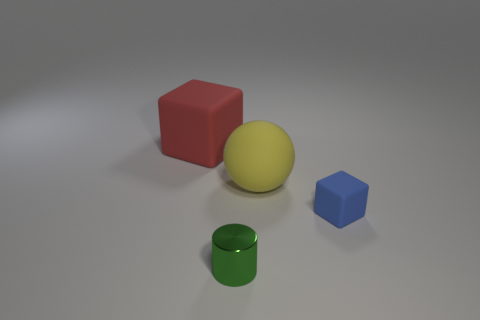Are there the same number of blue objects in front of the tiny blue thing and red things that are to the left of the metal thing?
Your answer should be very brief. No. The small shiny object has what color?
Your answer should be compact. Green. How many things are large things on the right side of the large red cube or small purple cylinders?
Your answer should be very brief. 1. There is a thing on the left side of the tiny green cylinder; is it the same size as the object that is in front of the small blue matte object?
Offer a terse response. No. Is there anything else that has the same material as the green object?
Offer a terse response. No. How many things are either big rubber objects that are on the right side of the big red matte cube or cubes on the right side of the rubber ball?
Provide a succinct answer. 2. Does the green cylinder have the same material as the large object to the left of the cylinder?
Your answer should be very brief. No. The thing that is to the left of the tiny blue block and on the right side of the small metallic thing has what shape?
Make the answer very short. Sphere. How many other objects are there of the same color as the small cylinder?
Give a very brief answer. 0. What is the shape of the yellow object?
Provide a short and direct response. Sphere. 